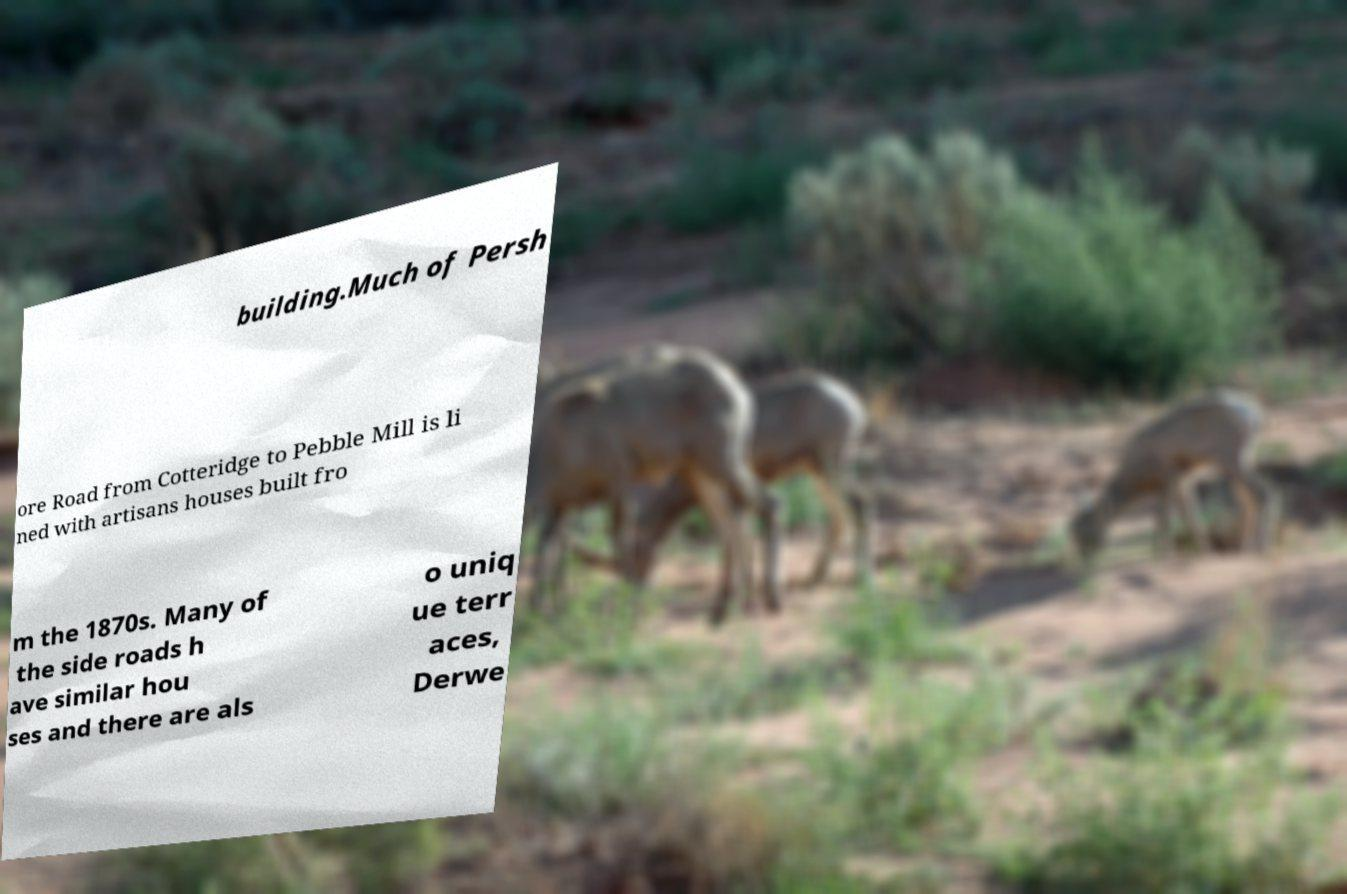Could you extract and type out the text from this image? building.Much of Persh ore Road from Cotteridge to Pebble Mill is li ned with artisans houses built fro m the 1870s. Many of the side roads h ave similar hou ses and there are als o uniq ue terr aces, Derwe 